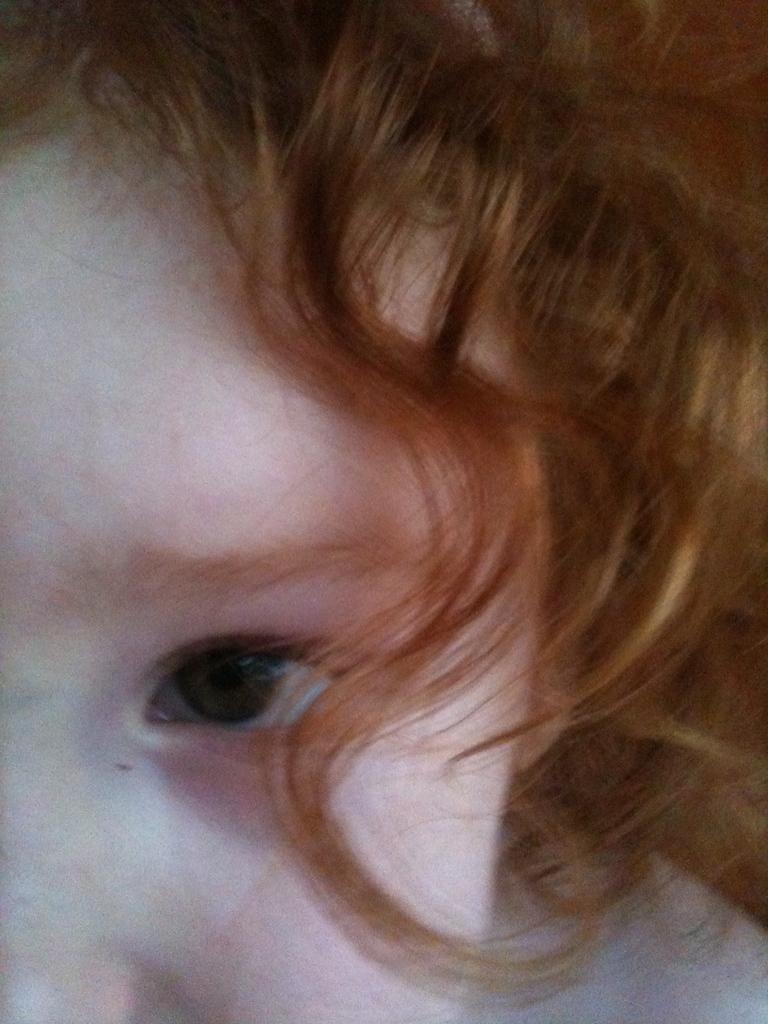What is the main subject of the image? The main subject of the image is a baby. Can you describe the baby's appearance? The baby has red hair. What type of ship can be seen in the image? There is no ship present in the image; it features a baby with red hair. How does the earthquake affect the baby in the image? There is no earthquake present in the image, so its effects cannot be observed. 